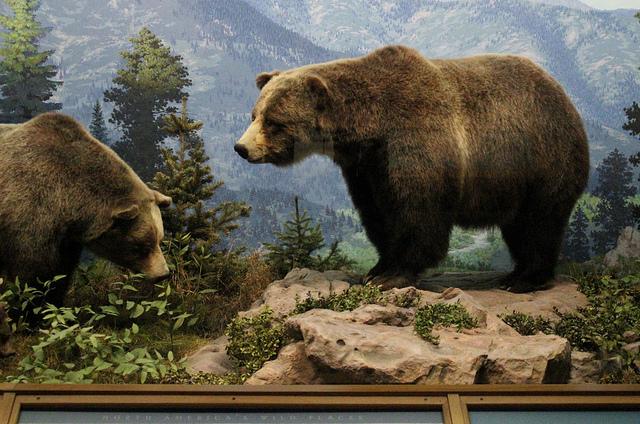How many bears are fully visible?
Concise answer only. 1. What color are the bears?
Write a very short answer. Brown. What type of tree is in the background?
Quick response, please. Pine. 